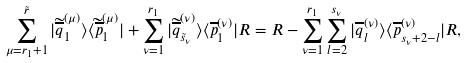<formula> <loc_0><loc_0><loc_500><loc_500>\sum _ { \mu = r _ { 1 } + 1 } ^ { \tilde { r } } | \widetilde { \overline { q } } _ { 1 } ^ { ( \mu ) } \rangle \langle \widetilde { \overline { p } } ^ { ( \mu ) } _ { 1 } | + \sum _ { \nu = 1 } ^ { r _ { 1 } } | \widetilde { \overline { q } } _ { \tilde { s } _ { \nu } } ^ { ( \nu ) } \rangle \langle \overline { p } ^ { ( \nu ) } _ { 1 } | R = R - \sum _ { \nu = 1 } ^ { r _ { 1 } } \sum _ { l = 2 } ^ { s _ { \nu } } | \overline { q } _ { l } ^ { ( \nu ) } \rangle \langle { \overline { p } } ^ { ( \nu ) } _ { s _ { \nu } + 2 - l } | R ,</formula> 